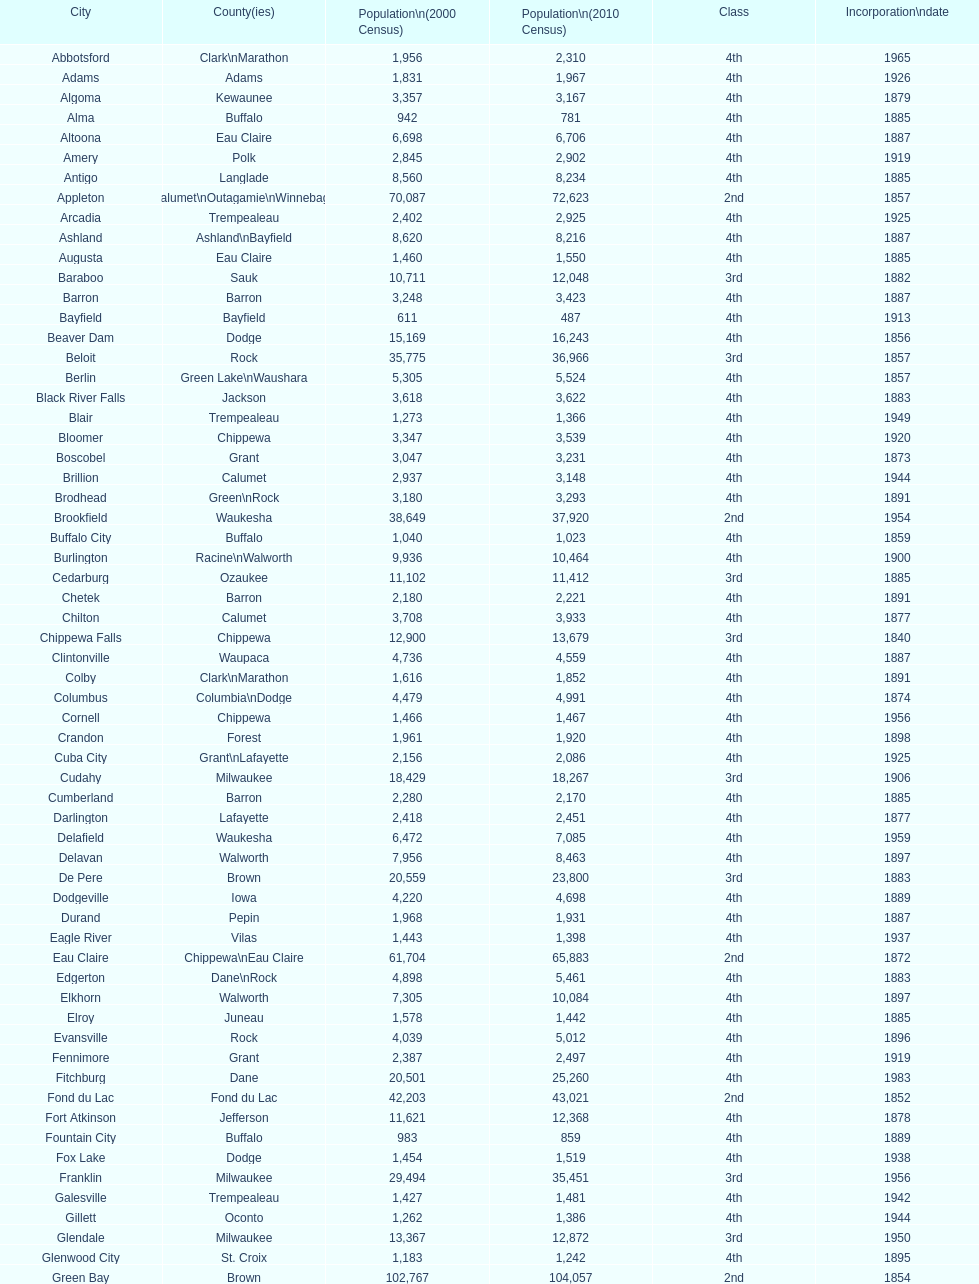How many cities have 1926 as their incorporation date? 2. 